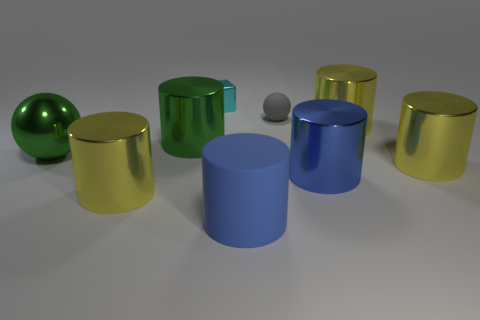Subtract all big blue rubber cylinders. How many cylinders are left? 5 Add 1 cyan blocks. How many objects exist? 10 Subtract all yellow cylinders. How many cylinders are left? 3 Subtract all blocks. How many objects are left? 8 Subtract 1 blocks. How many blocks are left? 0 Add 8 green things. How many green things are left? 10 Add 6 small red metal cubes. How many small red metal cubes exist? 6 Subtract 0 gray blocks. How many objects are left? 9 Subtract all yellow balls. Subtract all purple blocks. How many balls are left? 2 Subtract all purple cylinders. How many gray blocks are left? 0 